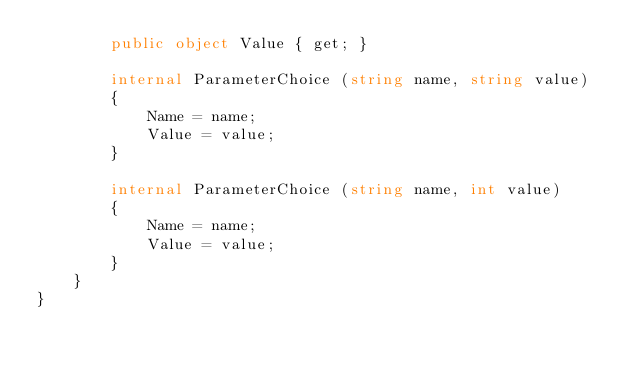Convert code to text. <code><loc_0><loc_0><loc_500><loc_500><_C#_>        public object Value { get; }

        internal ParameterChoice (string name, string value)
        {
            Name = name;
            Value = value;
        }

        internal ParameterChoice (string name, int value)
        {
            Name = name;
            Value = value;
        }
    }
}
</code> 